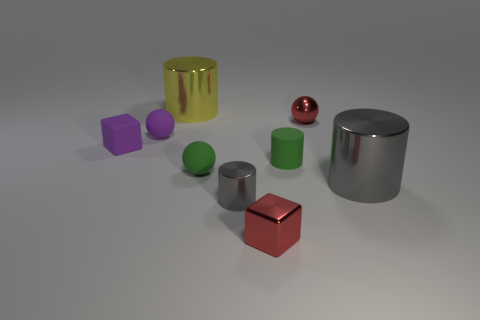Are there any other big things of the same shape as the yellow object?
Offer a very short reply. Yes. What material is the red block that is the same size as the purple sphere?
Offer a terse response. Metal. There is a shiny thing that is left of the small green matte sphere; what size is it?
Provide a short and direct response. Large. Does the gray metal thing to the right of the rubber cylinder have the same size as the cylinder behind the tiny matte block?
Your response must be concise. Yes. What number of small gray things have the same material as the big yellow cylinder?
Provide a succinct answer. 1. The matte cylinder has what color?
Your response must be concise. Green. There is a big gray shiny object; are there any metallic cylinders on the left side of it?
Make the answer very short. Yes. Do the tiny metallic sphere and the tiny metallic cube have the same color?
Your answer should be compact. Yes. What number of large metallic things have the same color as the small shiny cylinder?
Your answer should be compact. 1. There is a metal cylinder to the right of the object that is in front of the tiny gray thing; how big is it?
Ensure brevity in your answer.  Large. 